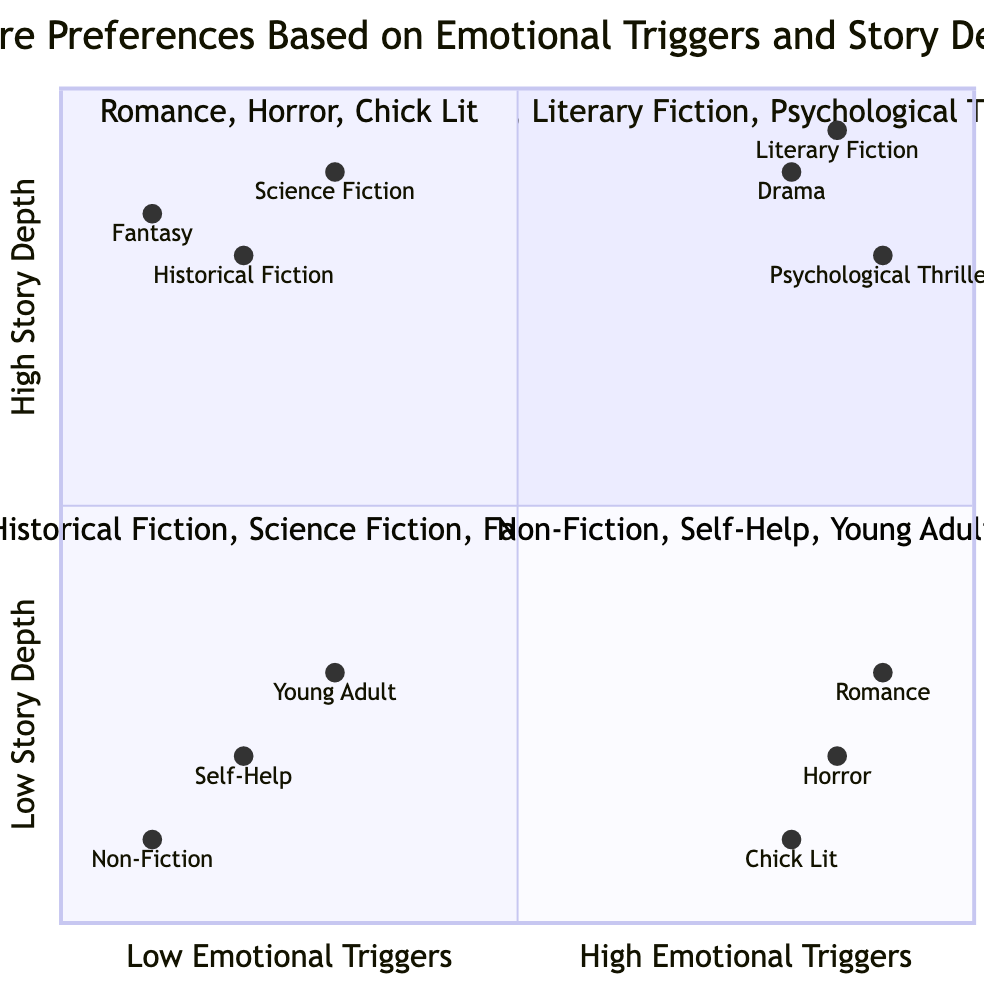What genres are in the High Emotional Triggers & High Story Depth quadrant? This quadrant features the genres that evoke strong emotions while also having complex narratives. According to the data provided, the genres listed are Drama, Literary Fiction, and Psychological Thriller.
Answer: Drama, Literary Fiction, Psychological Thriller How many genres fall into the High Emotional Triggers & Low Story Depth quadrant? This quadrant is identified as having genres with strong emotional appeal but simpler story structures. The genres in this quadrant are Romance, Horror, and Chick Lit, making a total of three genres.
Answer: 3 Which genre has the highest emotional trigger rating? By examining each genre's emotional trigger rating from the data, Psychological Thriller has the highest rating at 0.9.
Answer: Psychological Thriller What genre has the lowest story depth rating? To determine the genre with the lowest story depth rating, we compare all the genres listed. Non-Fiction has the lowest rating at 0.1.
Answer: Non-Fiction What is the emotional trigger rating for Historical Fiction? The emotional trigger rating for Historical Fiction is given directly in the coordinates provided. Its rating is 0.2.
Answer: 0.2 Which genre has the lowest emotional trigger rating while also having low story depth? The data indicates that among genres with low emotional triggers and low story depth, Non-Fiction has the lowest emotional trigger rating of 0.1.
Answer: Non-Fiction In the Low Emotional Triggers & High Story Depth quadrant, which genre has the highest story depth rating? The ratings show that Science Fiction has the highest story depth rating in this quadrant at 0.9, compared to other genres.
Answer: Science Fiction How does the story depth of Horror compare to that of Drama? Assessing the story depth ratings, Horror has a rating of 0.2, while Drama has a rating of 0.9, indicating that Drama has a significantly higher story depth than Horror.
Answer: Higher How many quadrants are represented in this diagram? The diagram represents four distinct quadrants related to the emotional triggers and story depth of genres.
Answer: 4 Which genre is categorized under both High Emotional Triggers and High Story Depth? According to the data provided, the genres categorized as both High Emotional Triggers and High Story Depth include Drama, Literary Fiction, and Psychological Thriller.
Answer: Drama, Literary Fiction, Psychological Thriller 